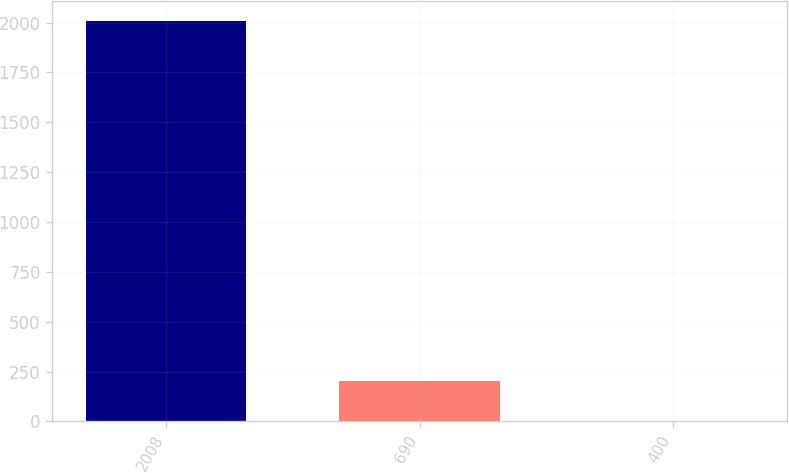Convert chart. <chart><loc_0><loc_0><loc_500><loc_500><bar_chart><fcel>2008<fcel>690<fcel>400<nl><fcel>2007<fcel>204.3<fcel>4<nl></chart> 